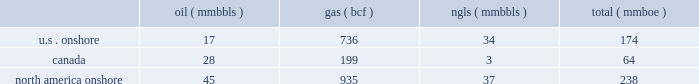Likely than not that some portion or all of the deferred tax assets will not be realized .
The accruals for deferred tax assets and liabilities are subject to a significant amount of judgment by management and are reviewed and adjusted routinely based on changes in facts and circumstances .
Material changes in these accruals may occur in the future , based on the progress of ongoing tax audits , changes in legislation and resolution of pending tax matters .
Forward-looking estimates we are providing our 2011 forward-looking estimates in this section .
These estimates were based on our examination of historical operating trends , the information used to prepare our december 31 , 2010 , reserve reports and other data in our possession or available from third parties .
The forward-looking estimates in this report were prepared assuming demand , curtailment , producibility and general market conditions for our oil , gas and ngls during 2011 will be similar to 2010 , unless otherwise noted .
We make reference to the 201cdisclosure regarding forward-looking statements 201d at the beginning of this report .
Amounts related to our canadian operations have been converted to u.s .
Dollars using an estimated average 2011 exchange rate of $ 0.95 dollar to $ 1.00 canadian dollar .
During 2011 , our operations are substantially comprised of our ongoing north america onshore operations .
We also have international operations in brazil and angola that we are divesting .
We have entered into agreements to sell our assets in brazil for $ 3.2 billion and our assets in angola for $ 70 million , plus contingent consideration .
As a result of these divestitures , all revenues , expenses and capital related to our international operations are reported as discontinued operations in our financial statements .
Additionally , all forward-looking estimates in this document exclude amounts related to our international operations , unless otherwise noted .
North america onshore operating items the following 2011 estimates relate only to our north america onshore assets .
Oil , gas and ngl production set forth below are our estimates of oil , gas and ngl production for 2011 .
We estimate that our combined oil , gas and ngl production will total approximately 236 to 240 mmboe .
( mmbbls ) ( mmbbls ) ( mmboe ) .
Oil and gas prices we expect our 2011 average prices for the oil and gas production from each of our operating areas to differ from the nymex price as set forth in the following table .
The expected ranges for prices are exclusive of the anticipated effects of the financial contracts presented in the 201ccommodity price risk management 201d section below .
The nymex price for oil is determined using the monthly average of settled prices on each trading day for benchmark west texas intermediate crude oil delivered at cushing , oklahoma .
The nymex price for gas is determined using the first-of-month south louisiana henry hub price index as published monthly in inside .
What percentage of north america gas comes from us onshore? 
Computations: ((736 / 935) * 100)
Answer: 78.71658. 